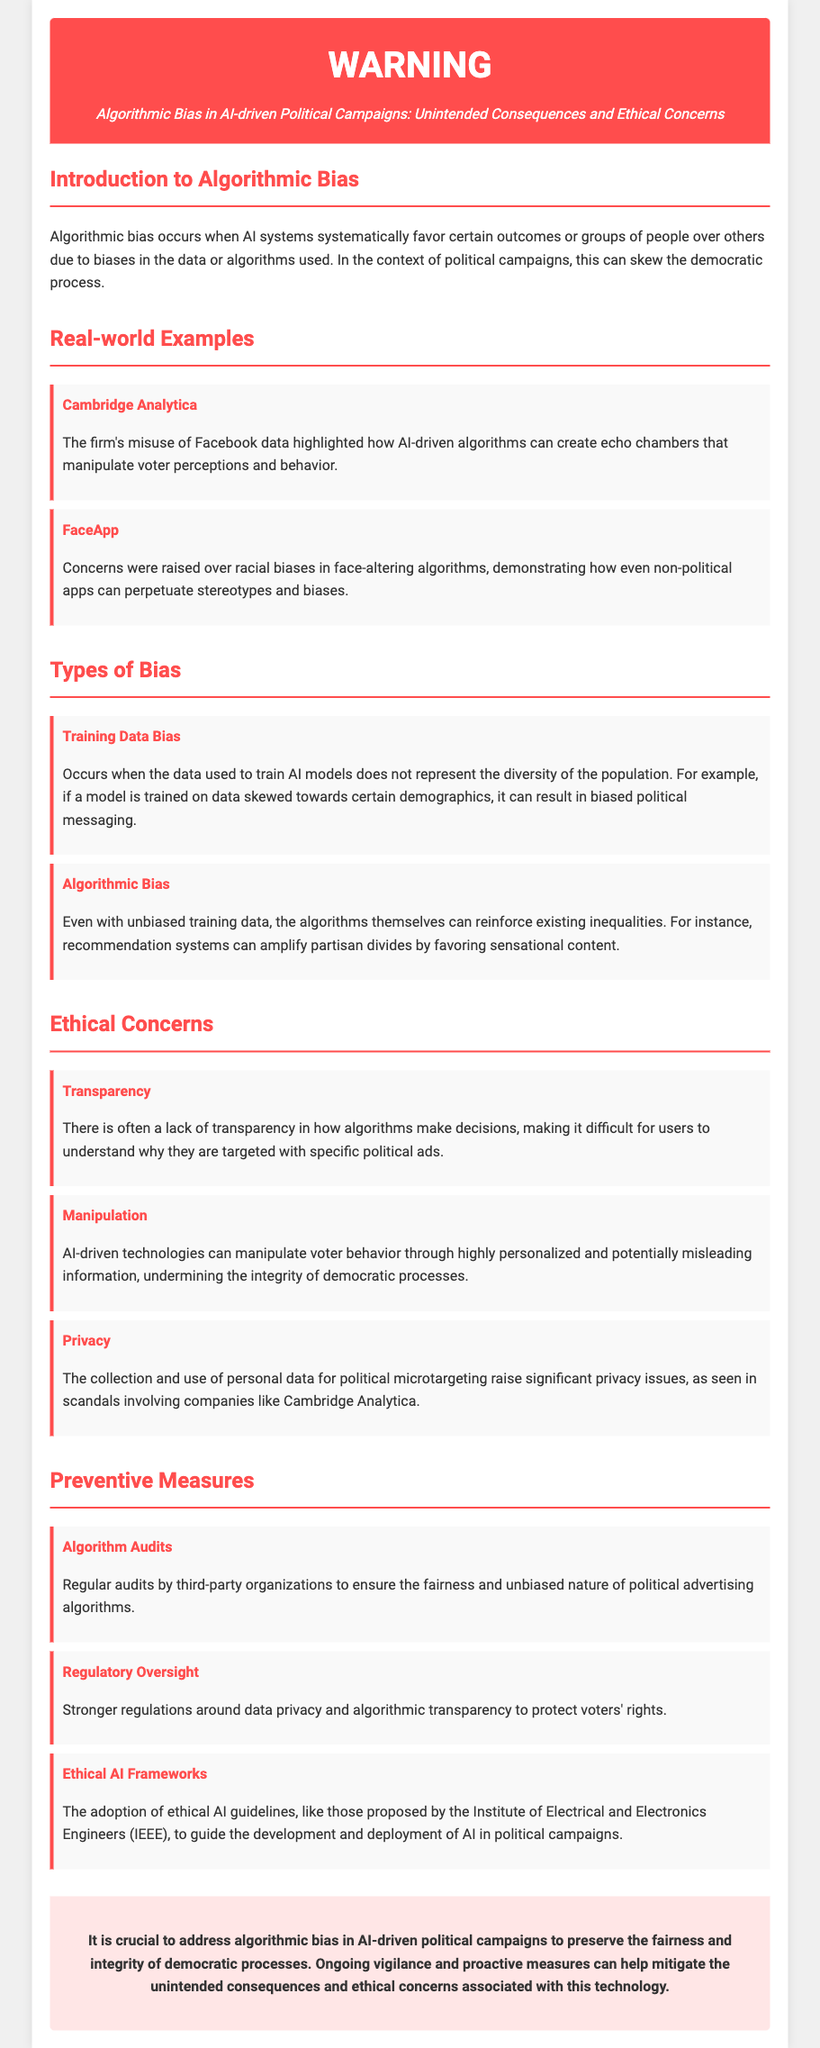what is algorithmic bias? Algorithmic bias is defined in the document as a systematic favoring of certain outcomes or groups due to biases in data or algorithms, which can skew the democratic process.
Answer: a systematic favoring of certain outcomes or groups which firm was highlighted in the document for misuse of Facebook data? The document mentions Cambridge Analytica as a firm that highlighted how AI-driven algorithms can manipulate voter perceptions.
Answer: Cambridge Analytica name one ethical concern related to algorithmic bias. The document lists several ethical concerns; one example is Transparency, which refers to a lack of clarity in how algorithms make decisions.
Answer: Transparency what is one type of bias mentioned? The document mentions various types of bias, including Training Data Bias, which occurs when the training data does not represent the diversity of the population.
Answer: Training Data Bias how many preventive measures are listed in the document? The document lists three preventive measures related to addressing algorithmic bias in political campaigns.
Answer: three what is the purpose of algorithm audits? The document states that algorithm audits aim to ensure the fairness and unbiased nature of political advertising algorithms through regular checks.
Answer: to ensure fairness which organization proposed ethical AI guidelines mentioned in the document? The Institute of Electrical and Electronics Engineers (IEEE) is mentioned in the document as an organization proposing ethical AI guidelines.
Answer: IEEE what color is the header of the document? The header of the document is described as having a background color of red, specifically #ff4d4d.
Answer: red 